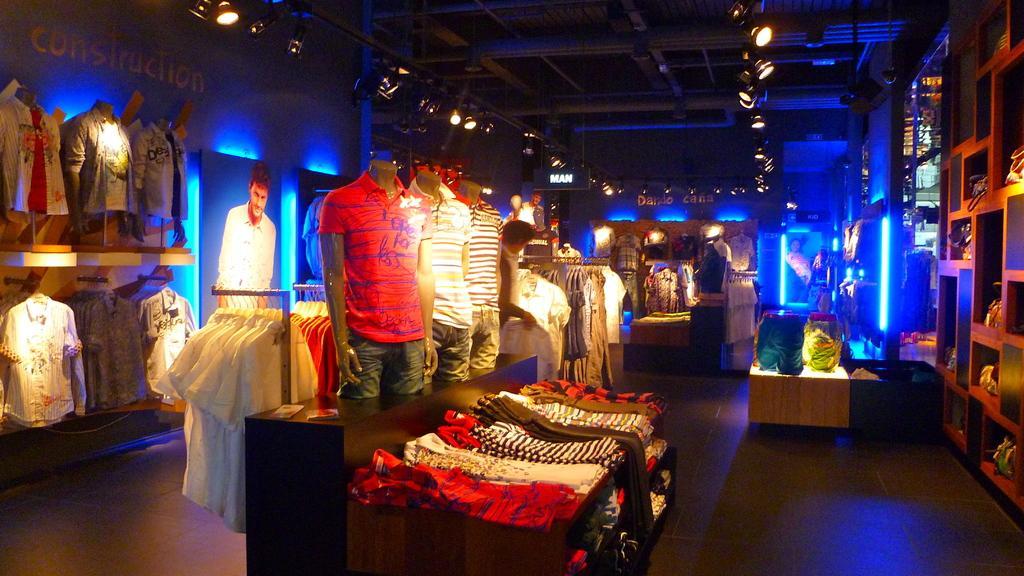Can you describe this image briefly? This image is clicked in a store. There are so many clothes in the middle. There are lights at the top. 